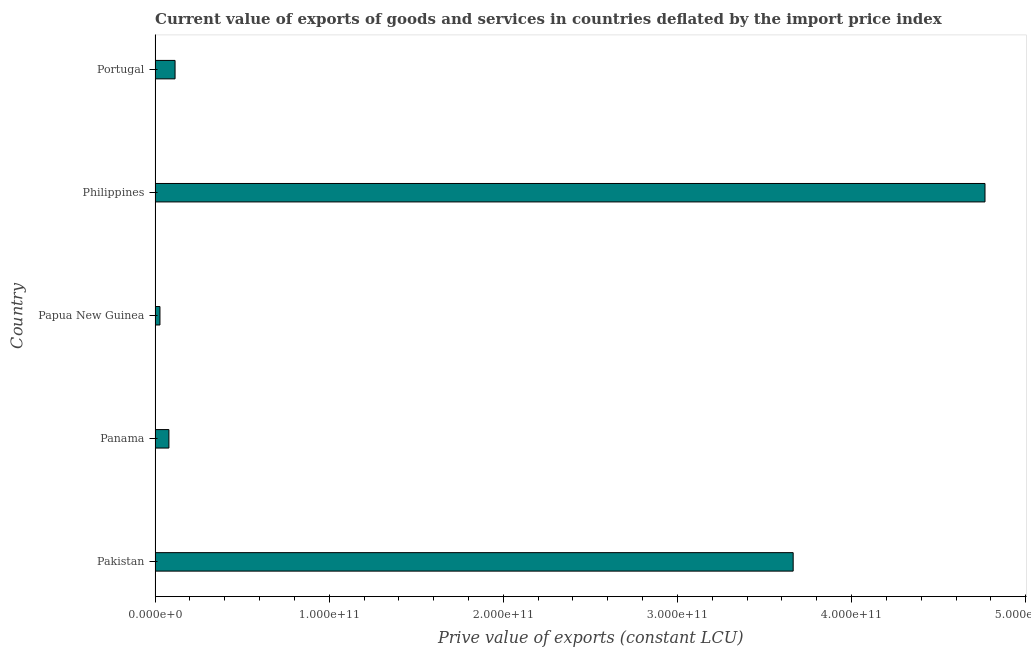Does the graph contain any zero values?
Ensure brevity in your answer.  No. Does the graph contain grids?
Make the answer very short. No. What is the title of the graph?
Provide a short and direct response. Current value of exports of goods and services in countries deflated by the import price index. What is the label or title of the X-axis?
Your response must be concise. Prive value of exports (constant LCU). What is the label or title of the Y-axis?
Provide a succinct answer. Country. What is the price value of exports in Philippines?
Your answer should be compact. 4.77e+11. Across all countries, what is the maximum price value of exports?
Make the answer very short. 4.77e+11. Across all countries, what is the minimum price value of exports?
Provide a short and direct response. 2.81e+09. In which country was the price value of exports maximum?
Provide a succinct answer. Philippines. In which country was the price value of exports minimum?
Ensure brevity in your answer.  Papua New Guinea. What is the sum of the price value of exports?
Give a very brief answer. 8.65e+11. What is the difference between the price value of exports in Panama and Papua New Guinea?
Offer a terse response. 5.14e+09. What is the average price value of exports per country?
Your answer should be very brief. 1.73e+11. What is the median price value of exports?
Give a very brief answer. 1.15e+1. In how many countries, is the price value of exports greater than 340000000000 LCU?
Provide a short and direct response. 2. What is the ratio of the price value of exports in Papua New Guinea to that in Philippines?
Your answer should be compact. 0.01. Is the price value of exports in Pakistan less than that in Panama?
Provide a succinct answer. No. Is the difference between the price value of exports in Philippines and Portugal greater than the difference between any two countries?
Provide a succinct answer. No. What is the difference between the highest and the second highest price value of exports?
Provide a succinct answer. 1.10e+11. Is the sum of the price value of exports in Pakistan and Philippines greater than the maximum price value of exports across all countries?
Give a very brief answer. Yes. What is the difference between the highest and the lowest price value of exports?
Make the answer very short. 4.74e+11. In how many countries, is the price value of exports greater than the average price value of exports taken over all countries?
Make the answer very short. 2. How many bars are there?
Provide a short and direct response. 5. What is the difference between two consecutive major ticks on the X-axis?
Provide a short and direct response. 1.00e+11. What is the Prive value of exports (constant LCU) of Pakistan?
Your response must be concise. 3.66e+11. What is the Prive value of exports (constant LCU) in Panama?
Make the answer very short. 7.95e+09. What is the Prive value of exports (constant LCU) in Papua New Guinea?
Give a very brief answer. 2.81e+09. What is the Prive value of exports (constant LCU) in Philippines?
Make the answer very short. 4.77e+11. What is the Prive value of exports (constant LCU) in Portugal?
Your answer should be compact. 1.15e+1. What is the difference between the Prive value of exports (constant LCU) in Pakistan and Panama?
Provide a short and direct response. 3.59e+11. What is the difference between the Prive value of exports (constant LCU) in Pakistan and Papua New Guinea?
Provide a short and direct response. 3.64e+11. What is the difference between the Prive value of exports (constant LCU) in Pakistan and Philippines?
Make the answer very short. -1.10e+11. What is the difference between the Prive value of exports (constant LCU) in Pakistan and Portugal?
Offer a very short reply. 3.55e+11. What is the difference between the Prive value of exports (constant LCU) in Panama and Papua New Guinea?
Your answer should be very brief. 5.14e+09. What is the difference between the Prive value of exports (constant LCU) in Panama and Philippines?
Offer a terse response. -4.69e+11. What is the difference between the Prive value of exports (constant LCU) in Panama and Portugal?
Provide a short and direct response. -3.53e+09. What is the difference between the Prive value of exports (constant LCU) in Papua New Guinea and Philippines?
Your answer should be compact. -4.74e+11. What is the difference between the Prive value of exports (constant LCU) in Papua New Guinea and Portugal?
Provide a short and direct response. -8.67e+09. What is the difference between the Prive value of exports (constant LCU) in Philippines and Portugal?
Keep it short and to the point. 4.65e+11. What is the ratio of the Prive value of exports (constant LCU) in Pakistan to that in Panama?
Give a very brief answer. 46.1. What is the ratio of the Prive value of exports (constant LCU) in Pakistan to that in Papua New Guinea?
Give a very brief answer. 130.4. What is the ratio of the Prive value of exports (constant LCU) in Pakistan to that in Philippines?
Offer a very short reply. 0.77. What is the ratio of the Prive value of exports (constant LCU) in Pakistan to that in Portugal?
Offer a very short reply. 31.91. What is the ratio of the Prive value of exports (constant LCU) in Panama to that in Papua New Guinea?
Offer a terse response. 2.83. What is the ratio of the Prive value of exports (constant LCU) in Panama to that in Philippines?
Keep it short and to the point. 0.02. What is the ratio of the Prive value of exports (constant LCU) in Panama to that in Portugal?
Keep it short and to the point. 0.69. What is the ratio of the Prive value of exports (constant LCU) in Papua New Guinea to that in Philippines?
Offer a very short reply. 0.01. What is the ratio of the Prive value of exports (constant LCU) in Papua New Guinea to that in Portugal?
Ensure brevity in your answer.  0.24. What is the ratio of the Prive value of exports (constant LCU) in Philippines to that in Portugal?
Keep it short and to the point. 41.51. 